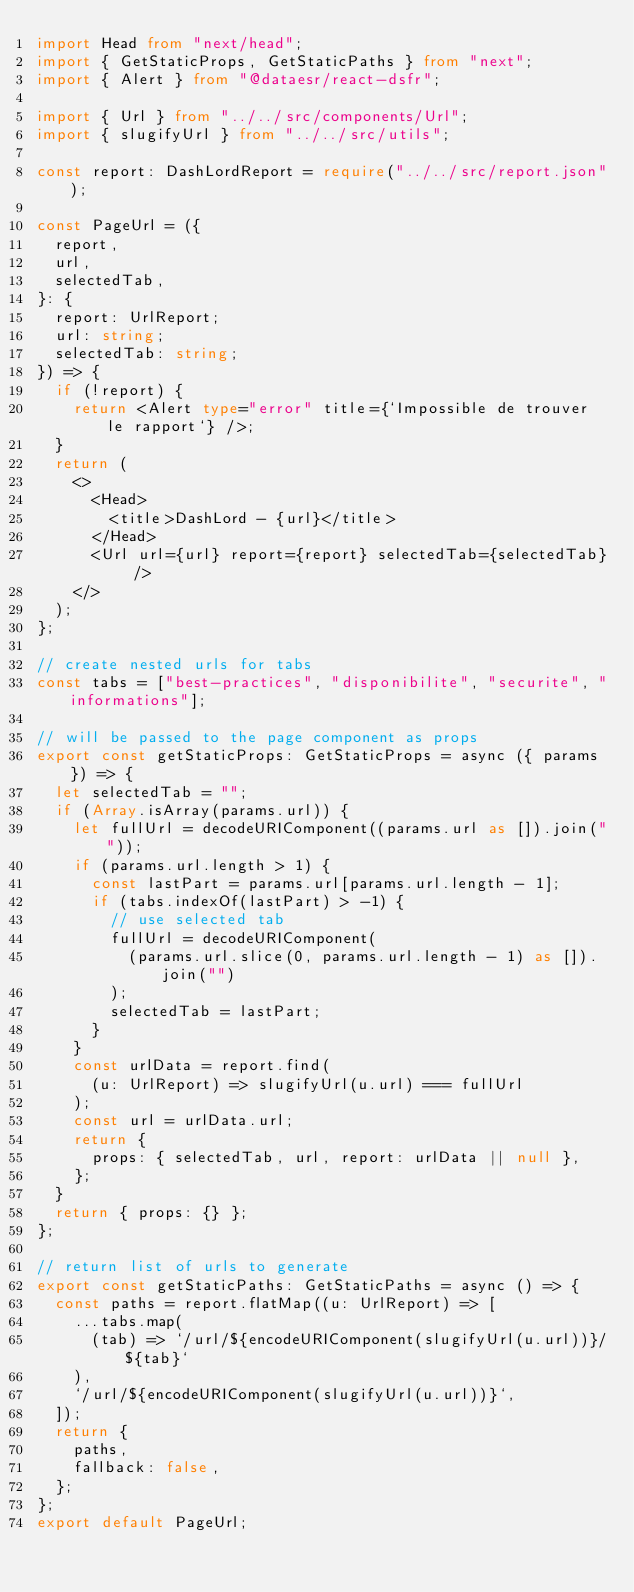Convert code to text. <code><loc_0><loc_0><loc_500><loc_500><_TypeScript_>import Head from "next/head";
import { GetStaticProps, GetStaticPaths } from "next";
import { Alert } from "@dataesr/react-dsfr";

import { Url } from "../../src/components/Url";
import { slugifyUrl } from "../../src/utils";

const report: DashLordReport = require("../../src/report.json");

const PageUrl = ({
  report,
  url,
  selectedTab,
}: {
  report: UrlReport;
  url: string;
  selectedTab: string;
}) => {
  if (!report) {
    return <Alert type="error" title={`Impossible de trouver le rapport`} />;
  }
  return (
    <>
      <Head>
        <title>DashLord - {url}</title>
      </Head>
      <Url url={url} report={report} selectedTab={selectedTab} />
    </>
  );
};

// create nested urls for tabs
const tabs = ["best-practices", "disponibilite", "securite", "informations"];

// will be passed to the page component as props
export const getStaticProps: GetStaticProps = async ({ params }) => {
  let selectedTab = "";
  if (Array.isArray(params.url)) {
    let fullUrl = decodeURIComponent((params.url as []).join(""));
    if (params.url.length > 1) {
      const lastPart = params.url[params.url.length - 1];
      if (tabs.indexOf(lastPart) > -1) {
        // use selected tab
        fullUrl = decodeURIComponent(
          (params.url.slice(0, params.url.length - 1) as []).join("")
        );
        selectedTab = lastPart;
      }
    }
    const urlData = report.find(
      (u: UrlReport) => slugifyUrl(u.url) === fullUrl
    );
    const url = urlData.url;
    return {
      props: { selectedTab, url, report: urlData || null },
    };
  }
  return { props: {} };
};

// return list of urls to generate
export const getStaticPaths: GetStaticPaths = async () => {
  const paths = report.flatMap((u: UrlReport) => [
    ...tabs.map(
      (tab) => `/url/${encodeURIComponent(slugifyUrl(u.url))}/${tab}`
    ),
    `/url/${encodeURIComponent(slugifyUrl(u.url))}`,
  ]);
  return {
    paths,
    fallback: false,
  };
};
export default PageUrl;
</code> 